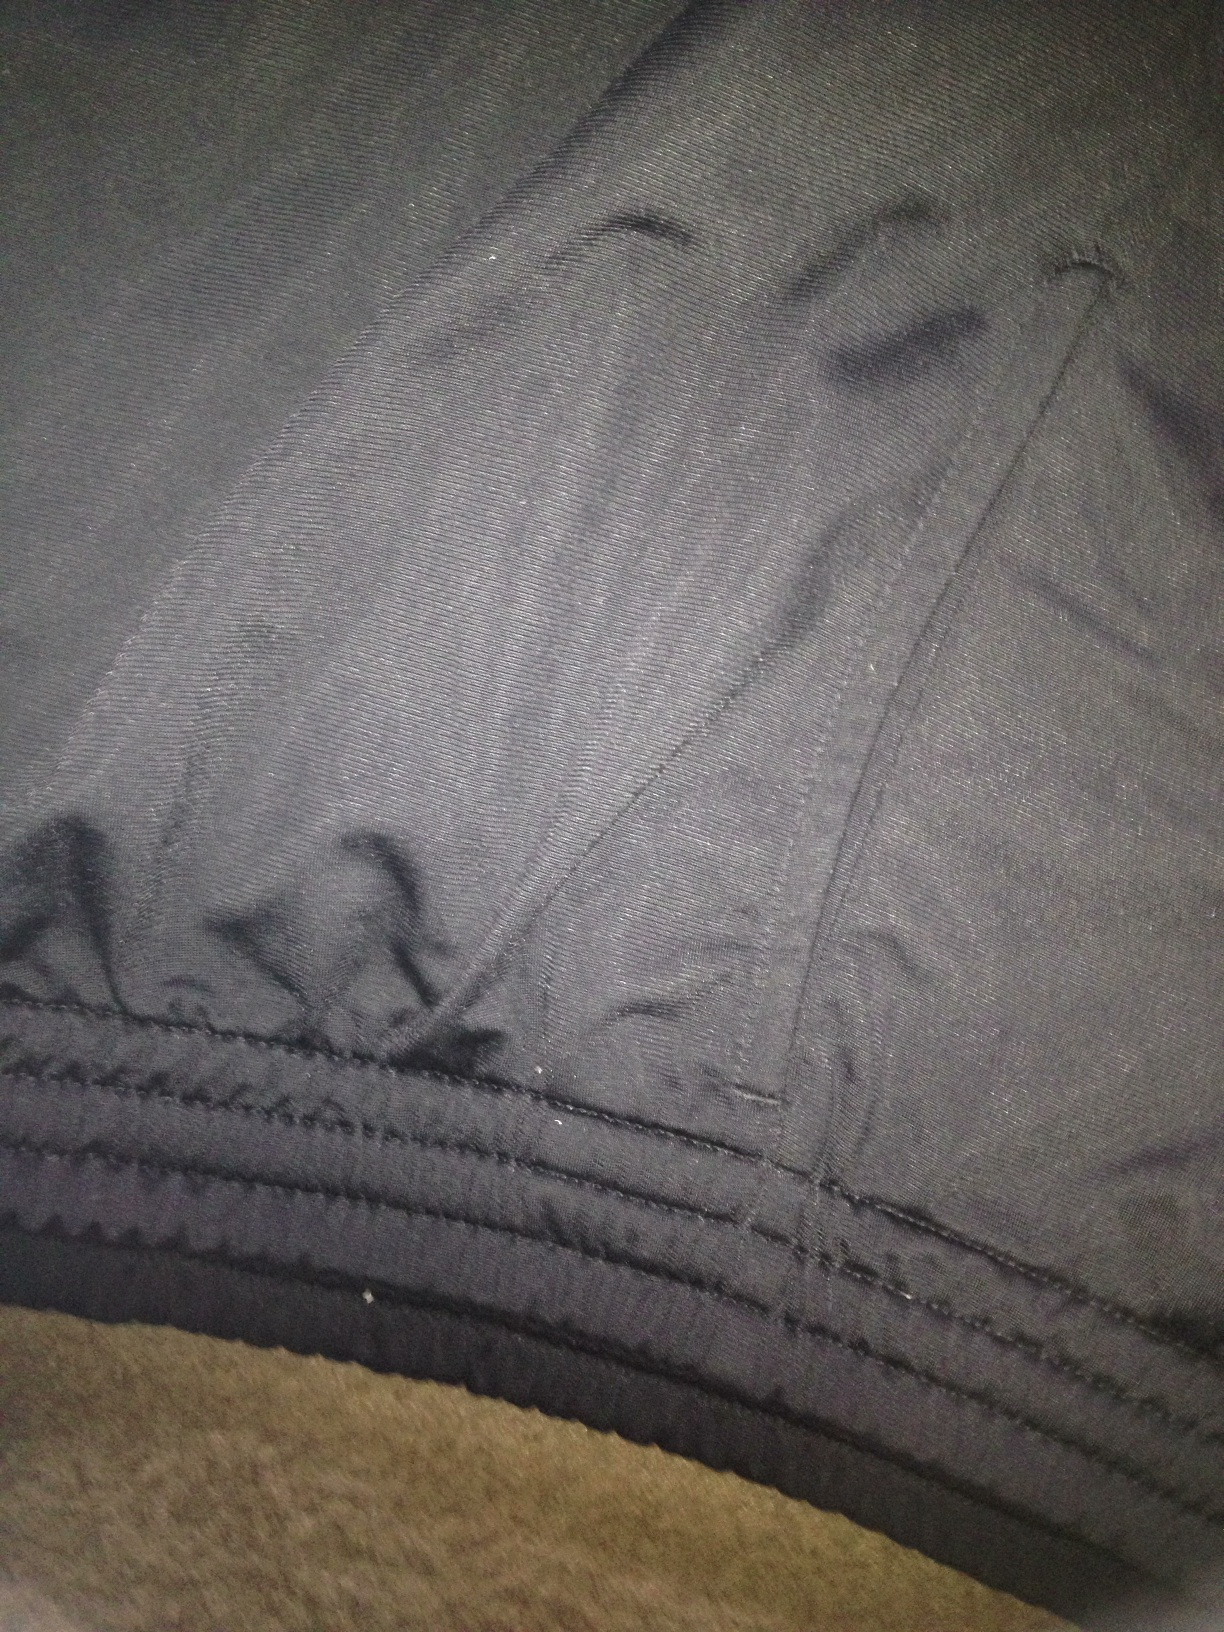Can you describe the texture of these pants? The texture of the pants looks to be a smooth, tightly woven fabric that might be comfortable to wear. Additionally, the presence of multiple stitch lines suggests durability and a focus on detail in their construction. Are these pants suitable for a formal occasion? While it is challenging to determine the exact type from a close-up image, these pants seem more casual due to their fabric and design details. They would be less suitable for a highly formal setting but could work well for semi-formal or casual events. 